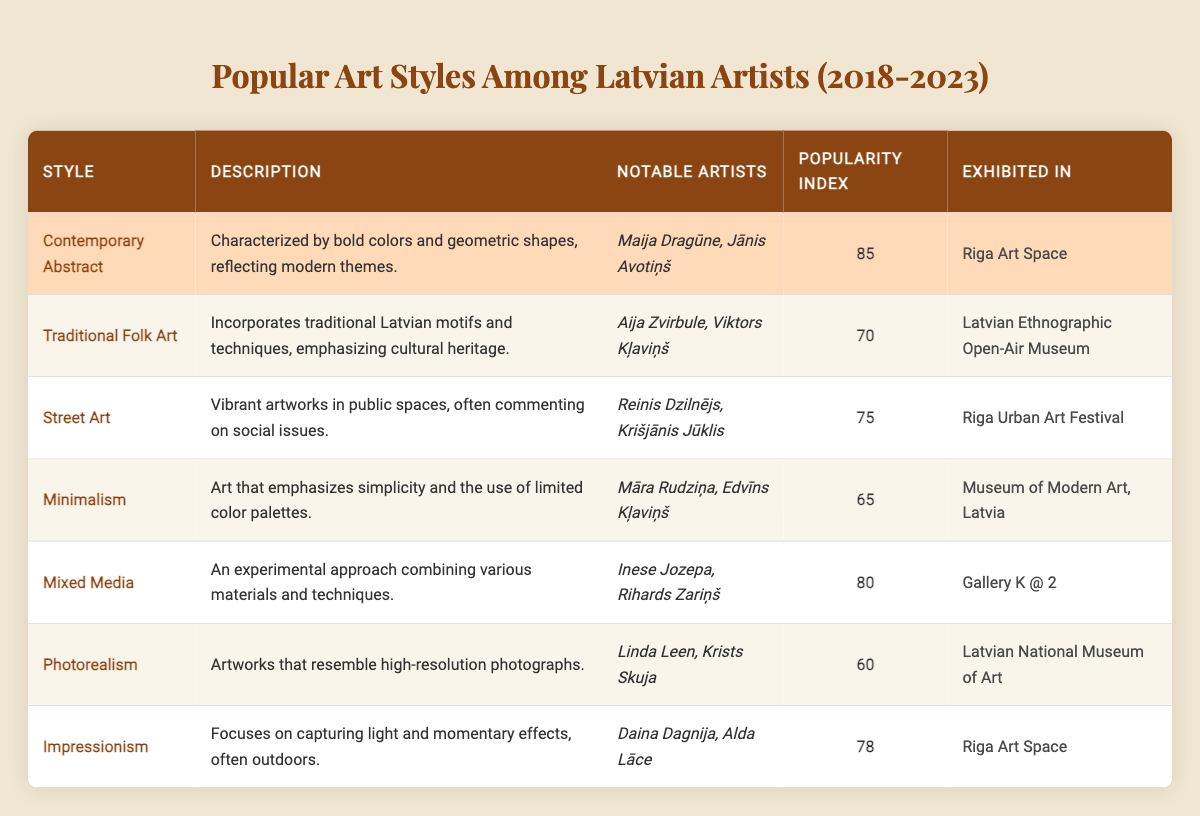What is the popularity index of Contemporary Abstract art? The popularity index of Contemporary Abstract is mentioned directly in the table, where it states a value of 85.
Answer: 85 Who are the notable artists associated with Traditional Folk Art? The table lists Aija Zvirbule and Viktors Kļaviņš as the notable artists for the Traditional Folk Art style.
Answer: Aija Zvirbule and Viktors Kļaviņš Which art style has the highest popularity index? By examining the table, Contemporary Abstract has the highest popularity index at 85 compared to the other styles listed.
Answer: Contemporary Abstract Is Street Art exhibited in the Museum of Modern Art, Latvia? The table specifies that Street Art is exhibited in the Riga Urban Art Festival, not the Museum of Modern Art. Thus, the statement is false.
Answer: No What is the average popularity index of the art styles listed? The popularity indices are 85, 70, 75, 65, 80, 60, and 78. Adding these gives 513, and there are 7 styles, so averaging is 513/7 = 73.29.
Answer: 73.29 Which styles are exhibited in Riga Art Space? The table identifies two styles: Contemporary Abstract and Impressionism as those exhibited in Riga Art Space.
Answer: Contemporary Abstract and Impressionism How many art styles have a popularity index above 75? By reviewing the popularity indices, Contemporary Abstract (85), Mixed Media (80), and Impressionism (78) are above 75. That totals 3 styles.
Answer: 3 What distinguishes Impressionism from Photorealism based on their descriptions? Impressionism focuses on capturing light and momentary effects, while Photorealism aims to resemble high-resolution photographs, indicating different artistic goals.
Answer: Different artistic goals Which art style features experimental approaches? The table lists Mixed Media as an art style that incorporates experimental approaches combining various materials and techniques.
Answer: Mixed Media Are there any notable artists associated with Minimalism? The table indeed lists Māra Rudziņa and Edvīns Kļaviņš as notable artists associated with the Minimalism style.
Answer: Yes 